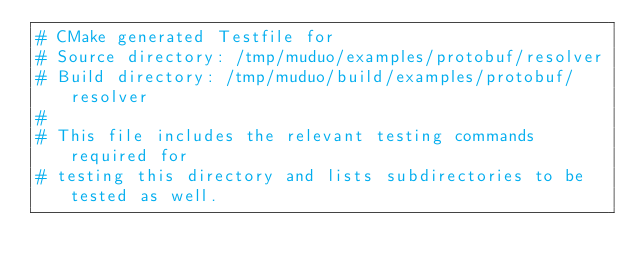<code> <loc_0><loc_0><loc_500><loc_500><_CMake_># CMake generated Testfile for 
# Source directory: /tmp/muduo/examples/protobuf/resolver
# Build directory: /tmp/muduo/build/examples/protobuf/resolver
# 
# This file includes the relevant testing commands required for 
# testing this directory and lists subdirectories to be tested as well.
</code> 